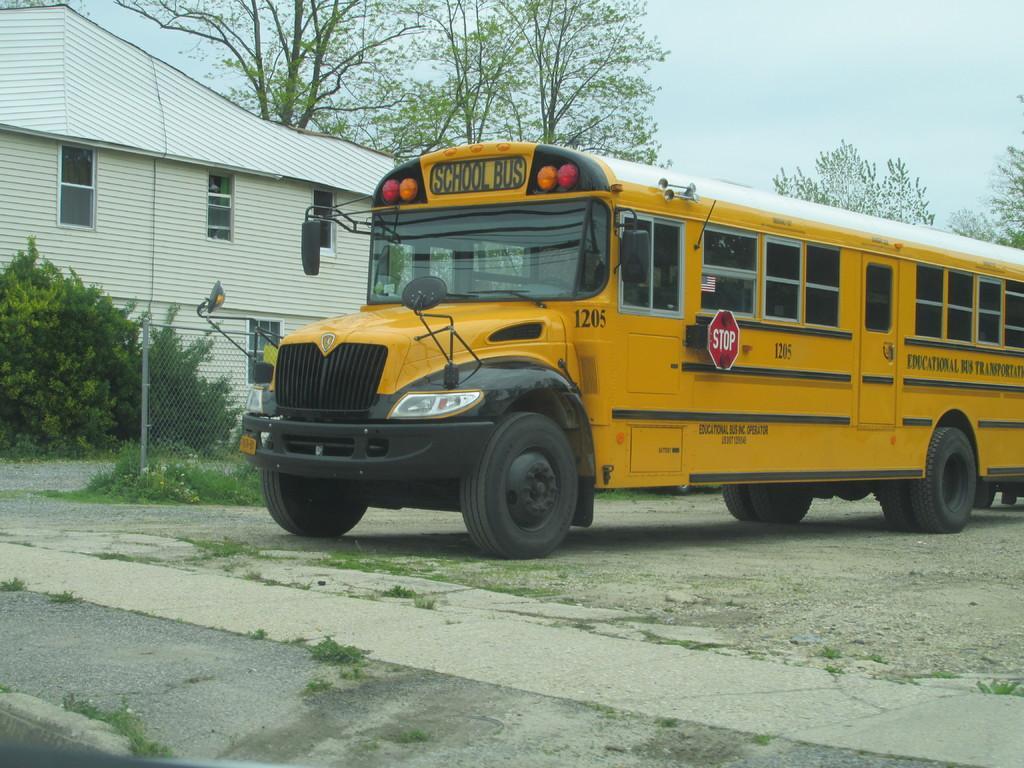Can you describe this image briefly? In the foreground of this image, there is a bus on the ground. Behind it, there is fencing, grass, plants, trees, building and the sky. 